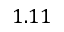Convert formula to latex. <formula><loc_0><loc_0><loc_500><loc_500>1 . 1 1</formula> 